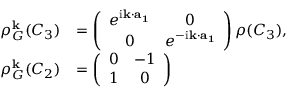Convert formula to latex. <formula><loc_0><loc_0><loc_500><loc_500>\begin{array} { r l } { \rho _ { G } ^ { k } ( C _ { 3 } ) } & { = \left ( \begin{array} { c c } { e ^ { i { k } \cdot { a _ { 1 } } } } & { 0 } \\ { 0 } & { e ^ { - i { k } \cdot { a _ { 1 } } } } \end{array} \right ) \rho ( C _ { 3 } ) , } \\ { \rho _ { G } ^ { k } ( C _ { 2 } ) } & { = \left ( \begin{array} { c c } { 0 } & { - 1 } \\ { 1 } & { 0 } \end{array} \right ) } \end{array}</formula> 